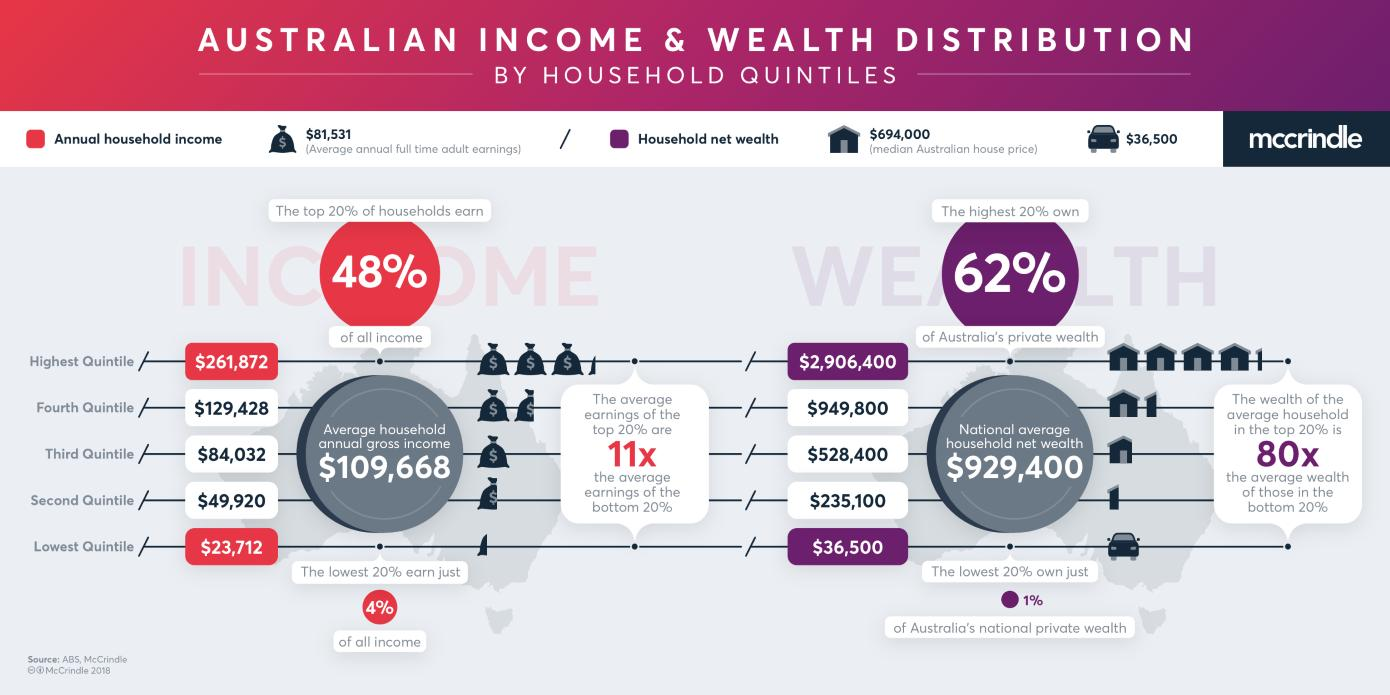Identify some key points in this picture. The fourth quintile earns significantly more than the lowest quintile, with a difference of $105,716. According to the data, the second quintile of Australian national private wealth owns more than the lowest quintile, with a difference of $198,600. The second quintile earns more than the lowest quintile by $26,208. The third quintile earns significantly more than the lowest quintile, with a difference of $60,320. 